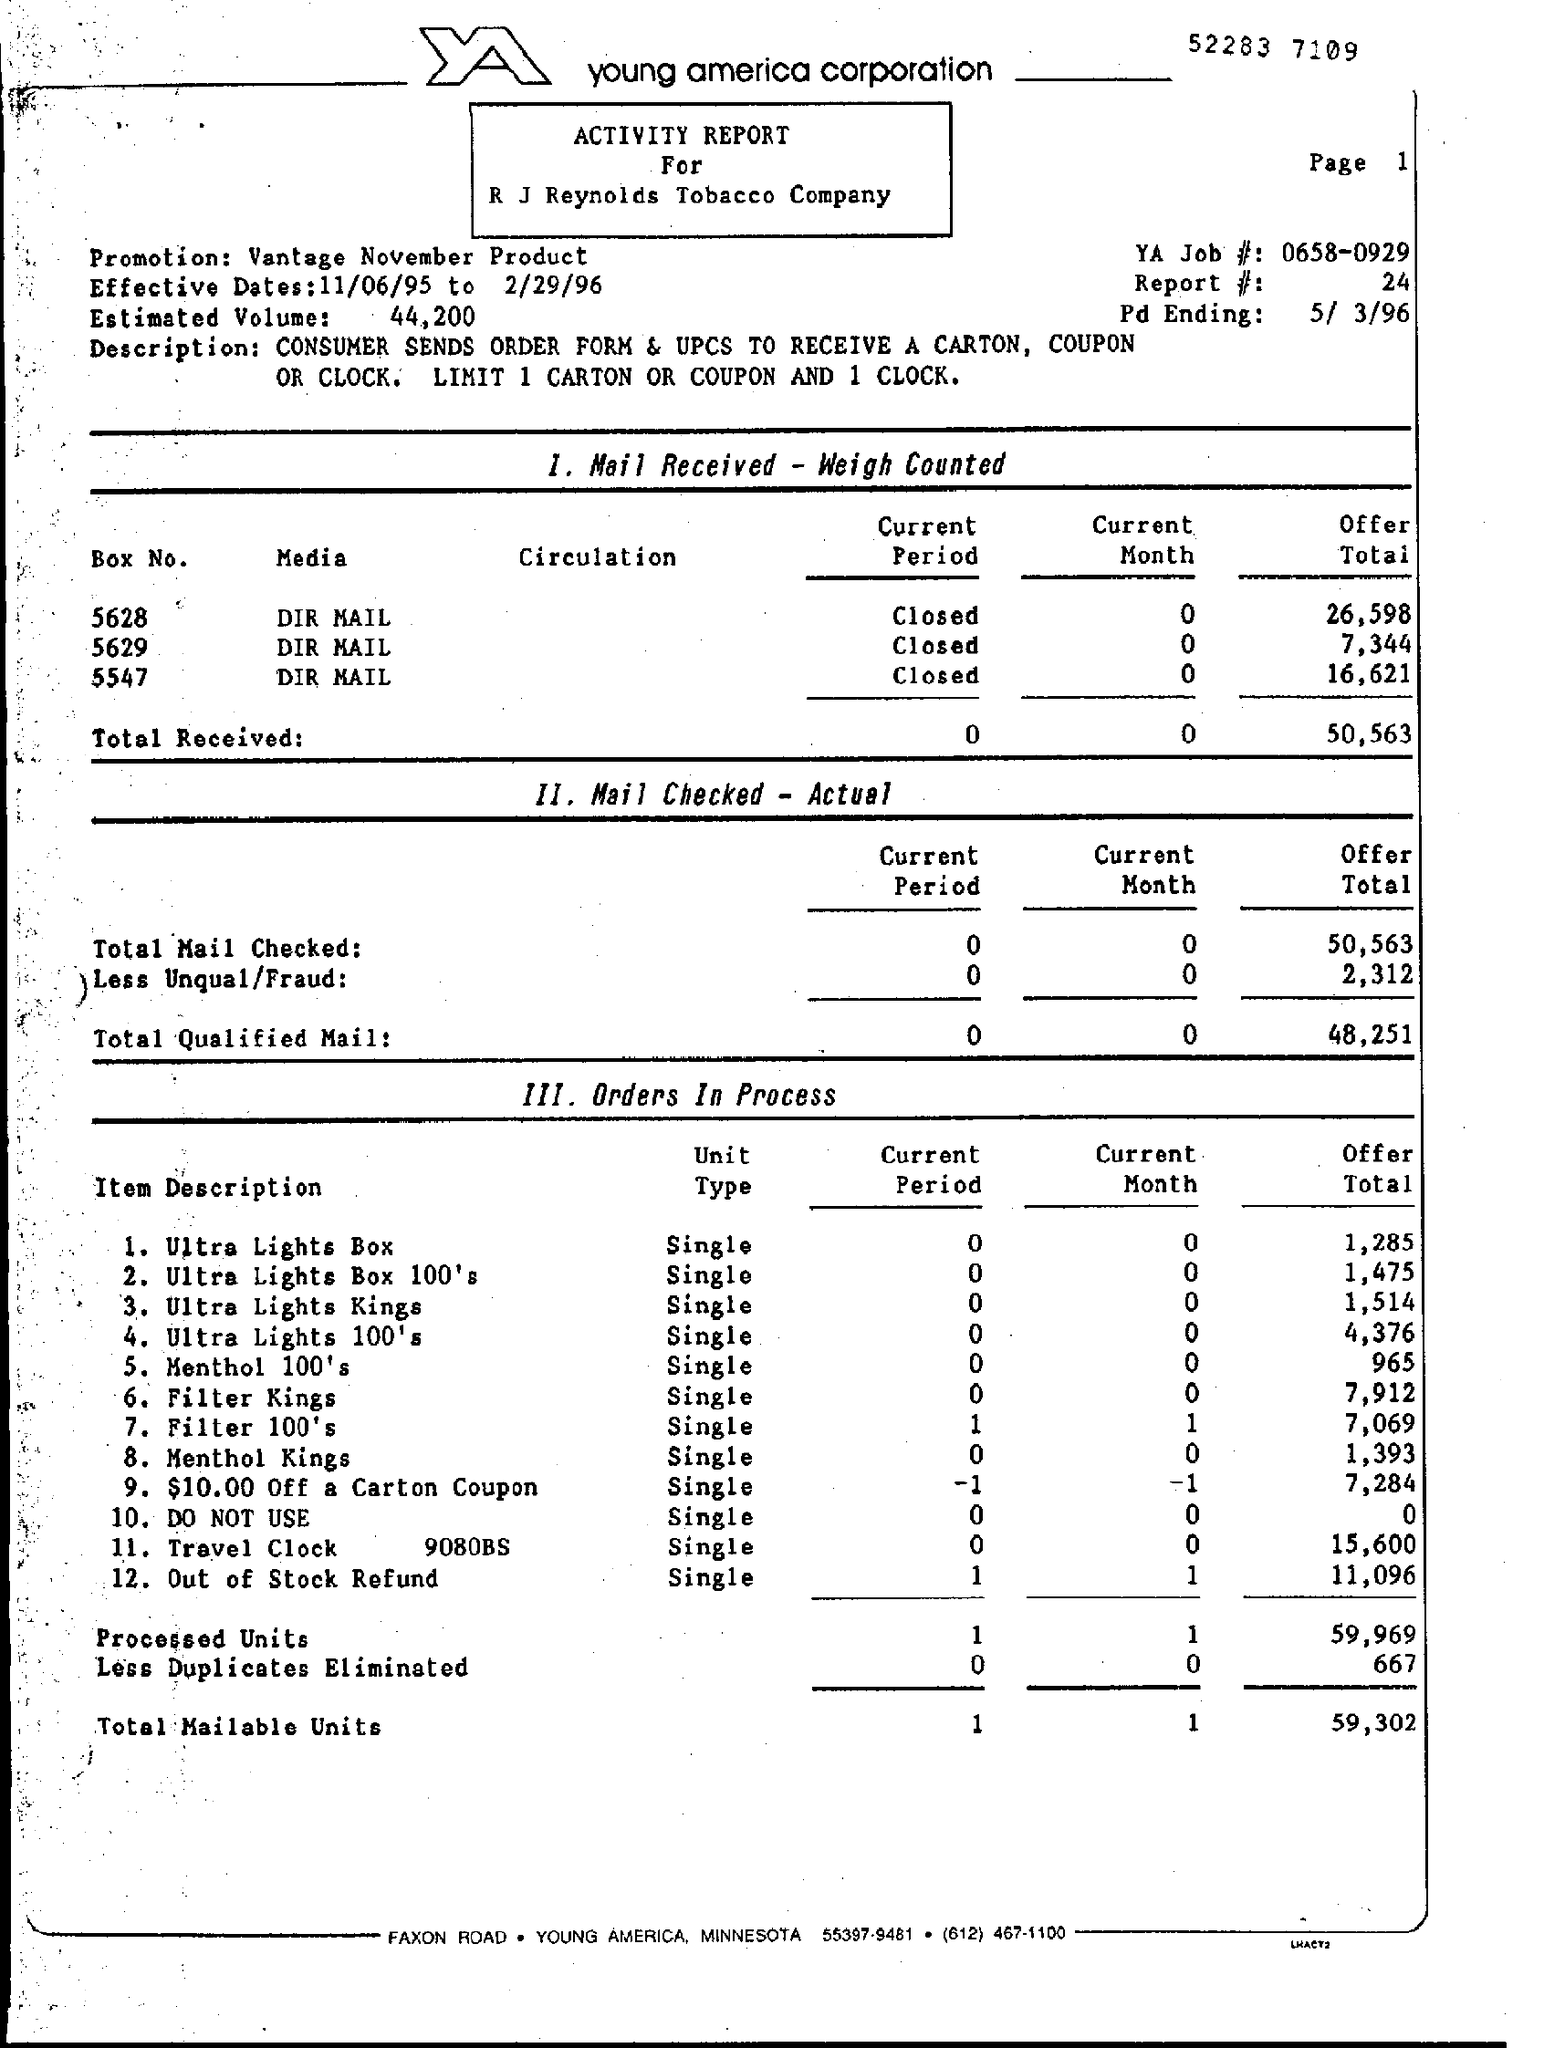What type of documentation is this?
Give a very brief answer. ACTIVITY REPORT For R J Reynolds Tobacco Company. Which firm is mentioned at the top of the page?
Ensure brevity in your answer.  Young america corporation. What is the number written at the top of the page?
Keep it short and to the point. 52283 7109. What is the YA Job #?
Give a very brief answer. 0658-0929. What is the promotion?
Offer a terse response. Vantage November Product. What are the effective dates?
Offer a very short reply. 11/06/95 to 2/29/96. What is the report #?
Your answer should be compact. 24. 